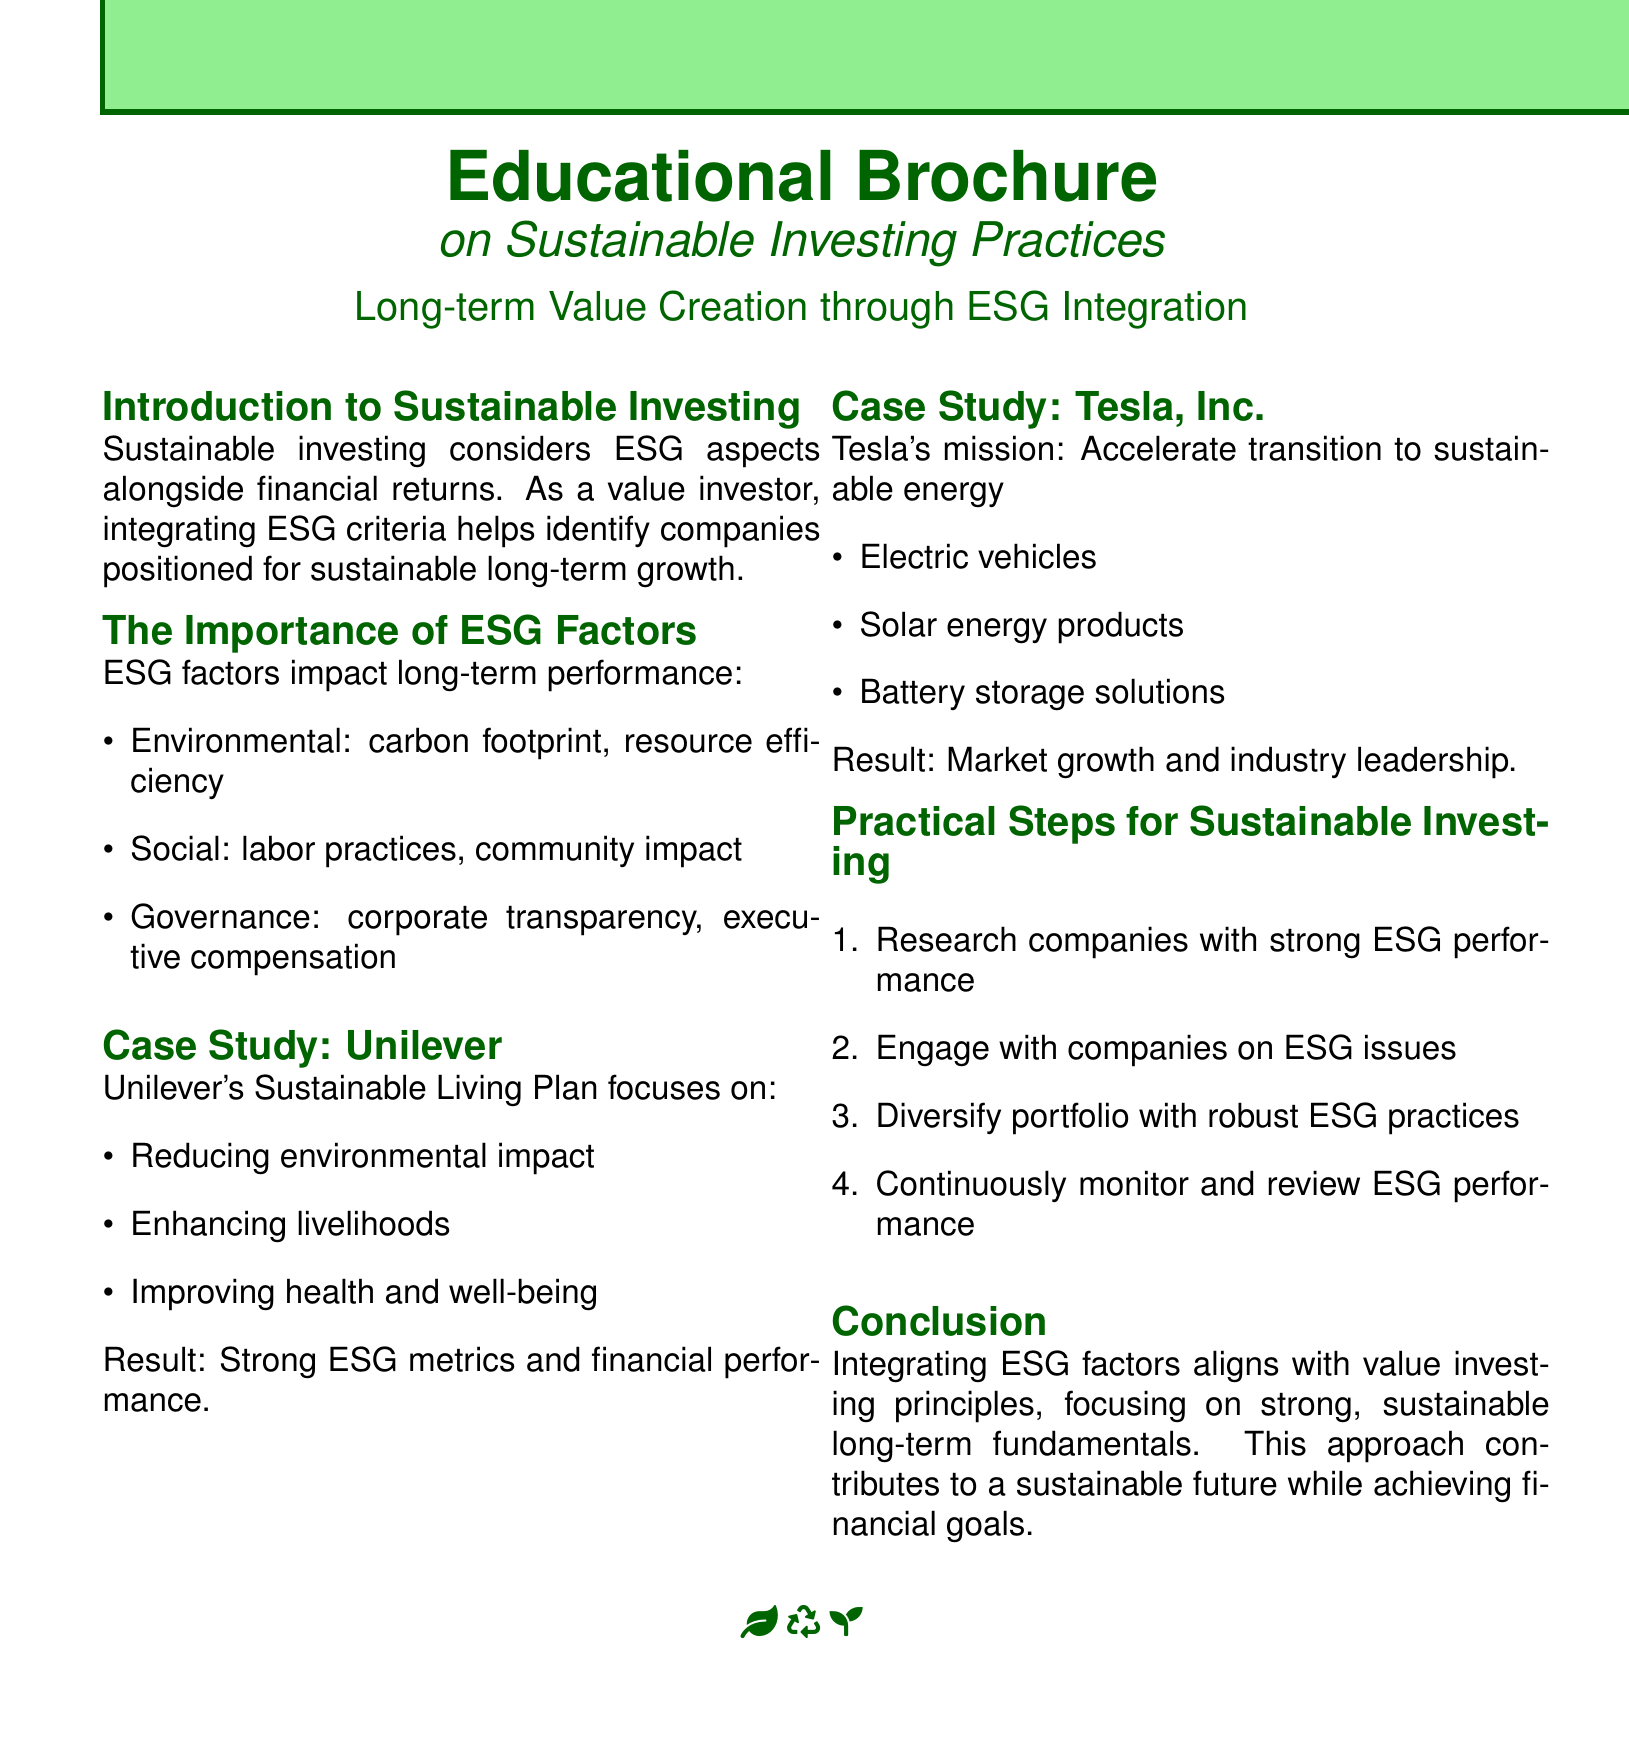What is the focus of Unilever's Sustainable Living Plan? The focus areas according to the document are reducing environmental impact, enhancing livelihoods, and improving health and well-being.
Answer: Reducing environmental impact, enhancing livelihoods, improving health and well-being What is Tesla's mission? The document outlines Tesla's mission as accelerating the transition to sustainable energy.
Answer: Accelerate transition to sustainable energy What is a practical step for sustainable investing mentioned in the brochure? One suggested practical step is to research companies with strong ESG performance.
Answer: Research companies with strong ESG performance How does integrating ESG factors align with investment principles? The document states that integrating ESG factors aligns with value investing principles focusing on strong, sustainable long-term fundamentals.
Answer: Aligns with value investing principles What aspect does the "Social" factor of ESG consider? The "Social" factor addresses labor practices and community impact according to the document.
Answer: Labor practices, community impact What type of document is this? The document is an educational brochure on sustainable investing practices.
Answer: Educational brochure What color is predominantly used in the document? The light green color is predominantly used throughout the document.
Answer: Light green 